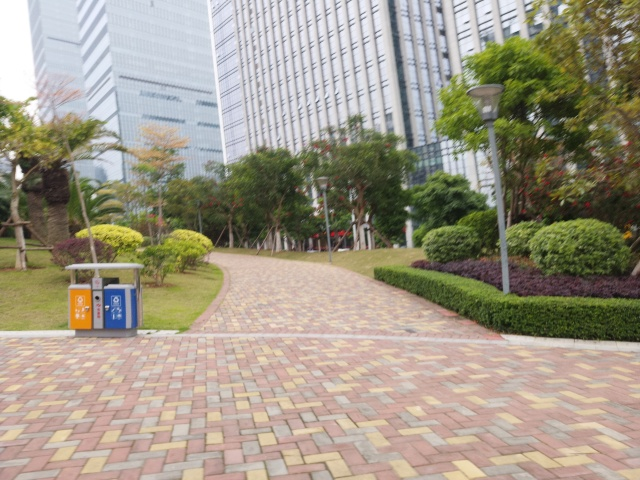Is the image blurry? While the image exhibits a slight lack of sharpness overall, implying a mild blur effect, it maintains sufficient detail to discern major elements within the scene such as the walkway, surrounding vegetation, and the urban backdrop. 